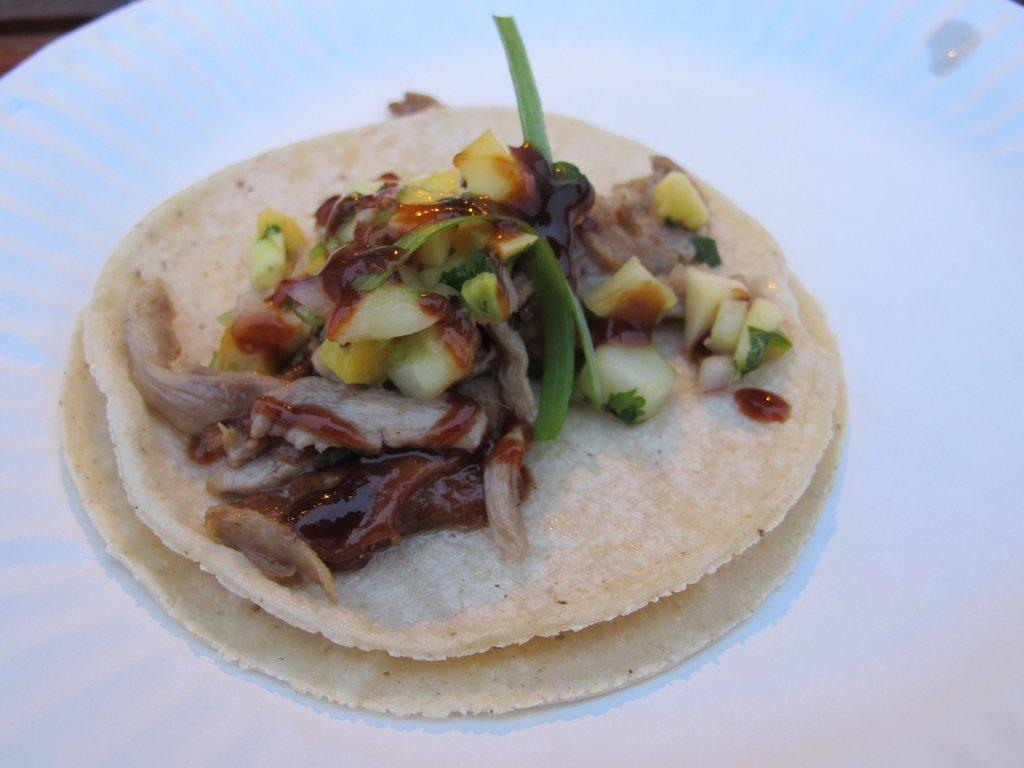What is on the plate that is visible in the image? There is food on a plate in the image. Where is the plate located in the image? The plate is placed on a table. How many books are stacked on the plate in the image? There are no books present on the plate or in the image. 